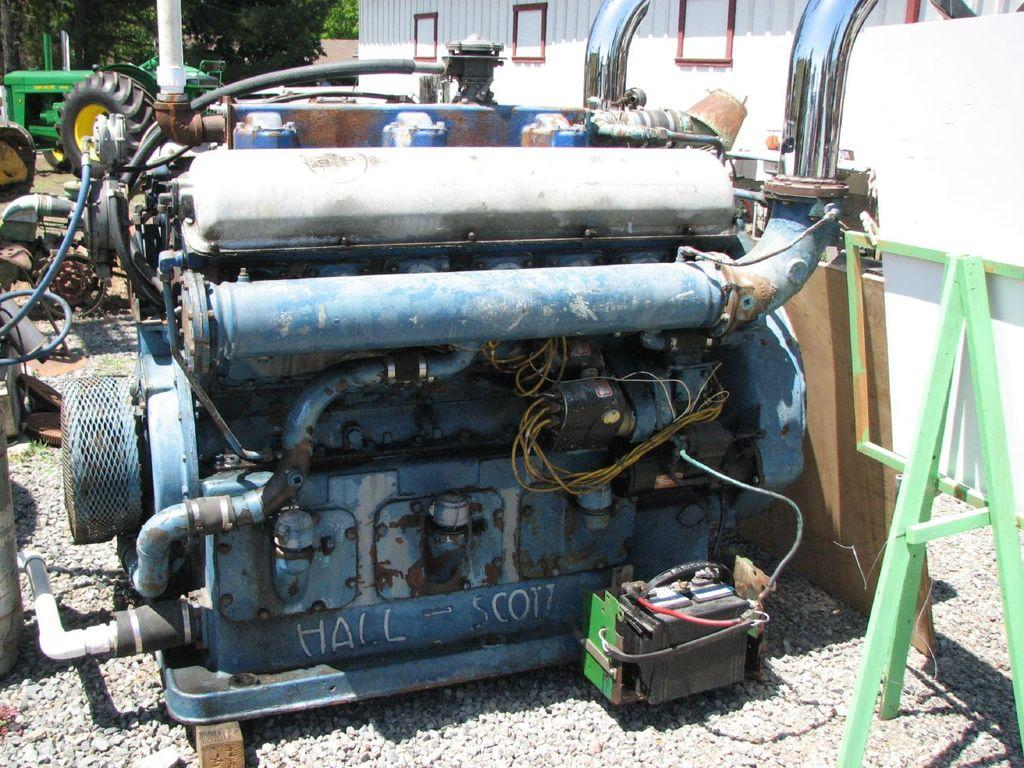What is the main object in the image? There is a machine in the image. What else can be seen in the image besides the machine? There is a vehicle in the image. What can be seen in the background of the image? There are trees in the background of the image. What type of birthday celebration is happening in the image? There is no indication of a birthday celebration in the image; it features a machine and a vehicle with trees in the background. How low is the machine in the image? The height of the machine cannot be determined from the image alone, as there is no reference point for comparison. 